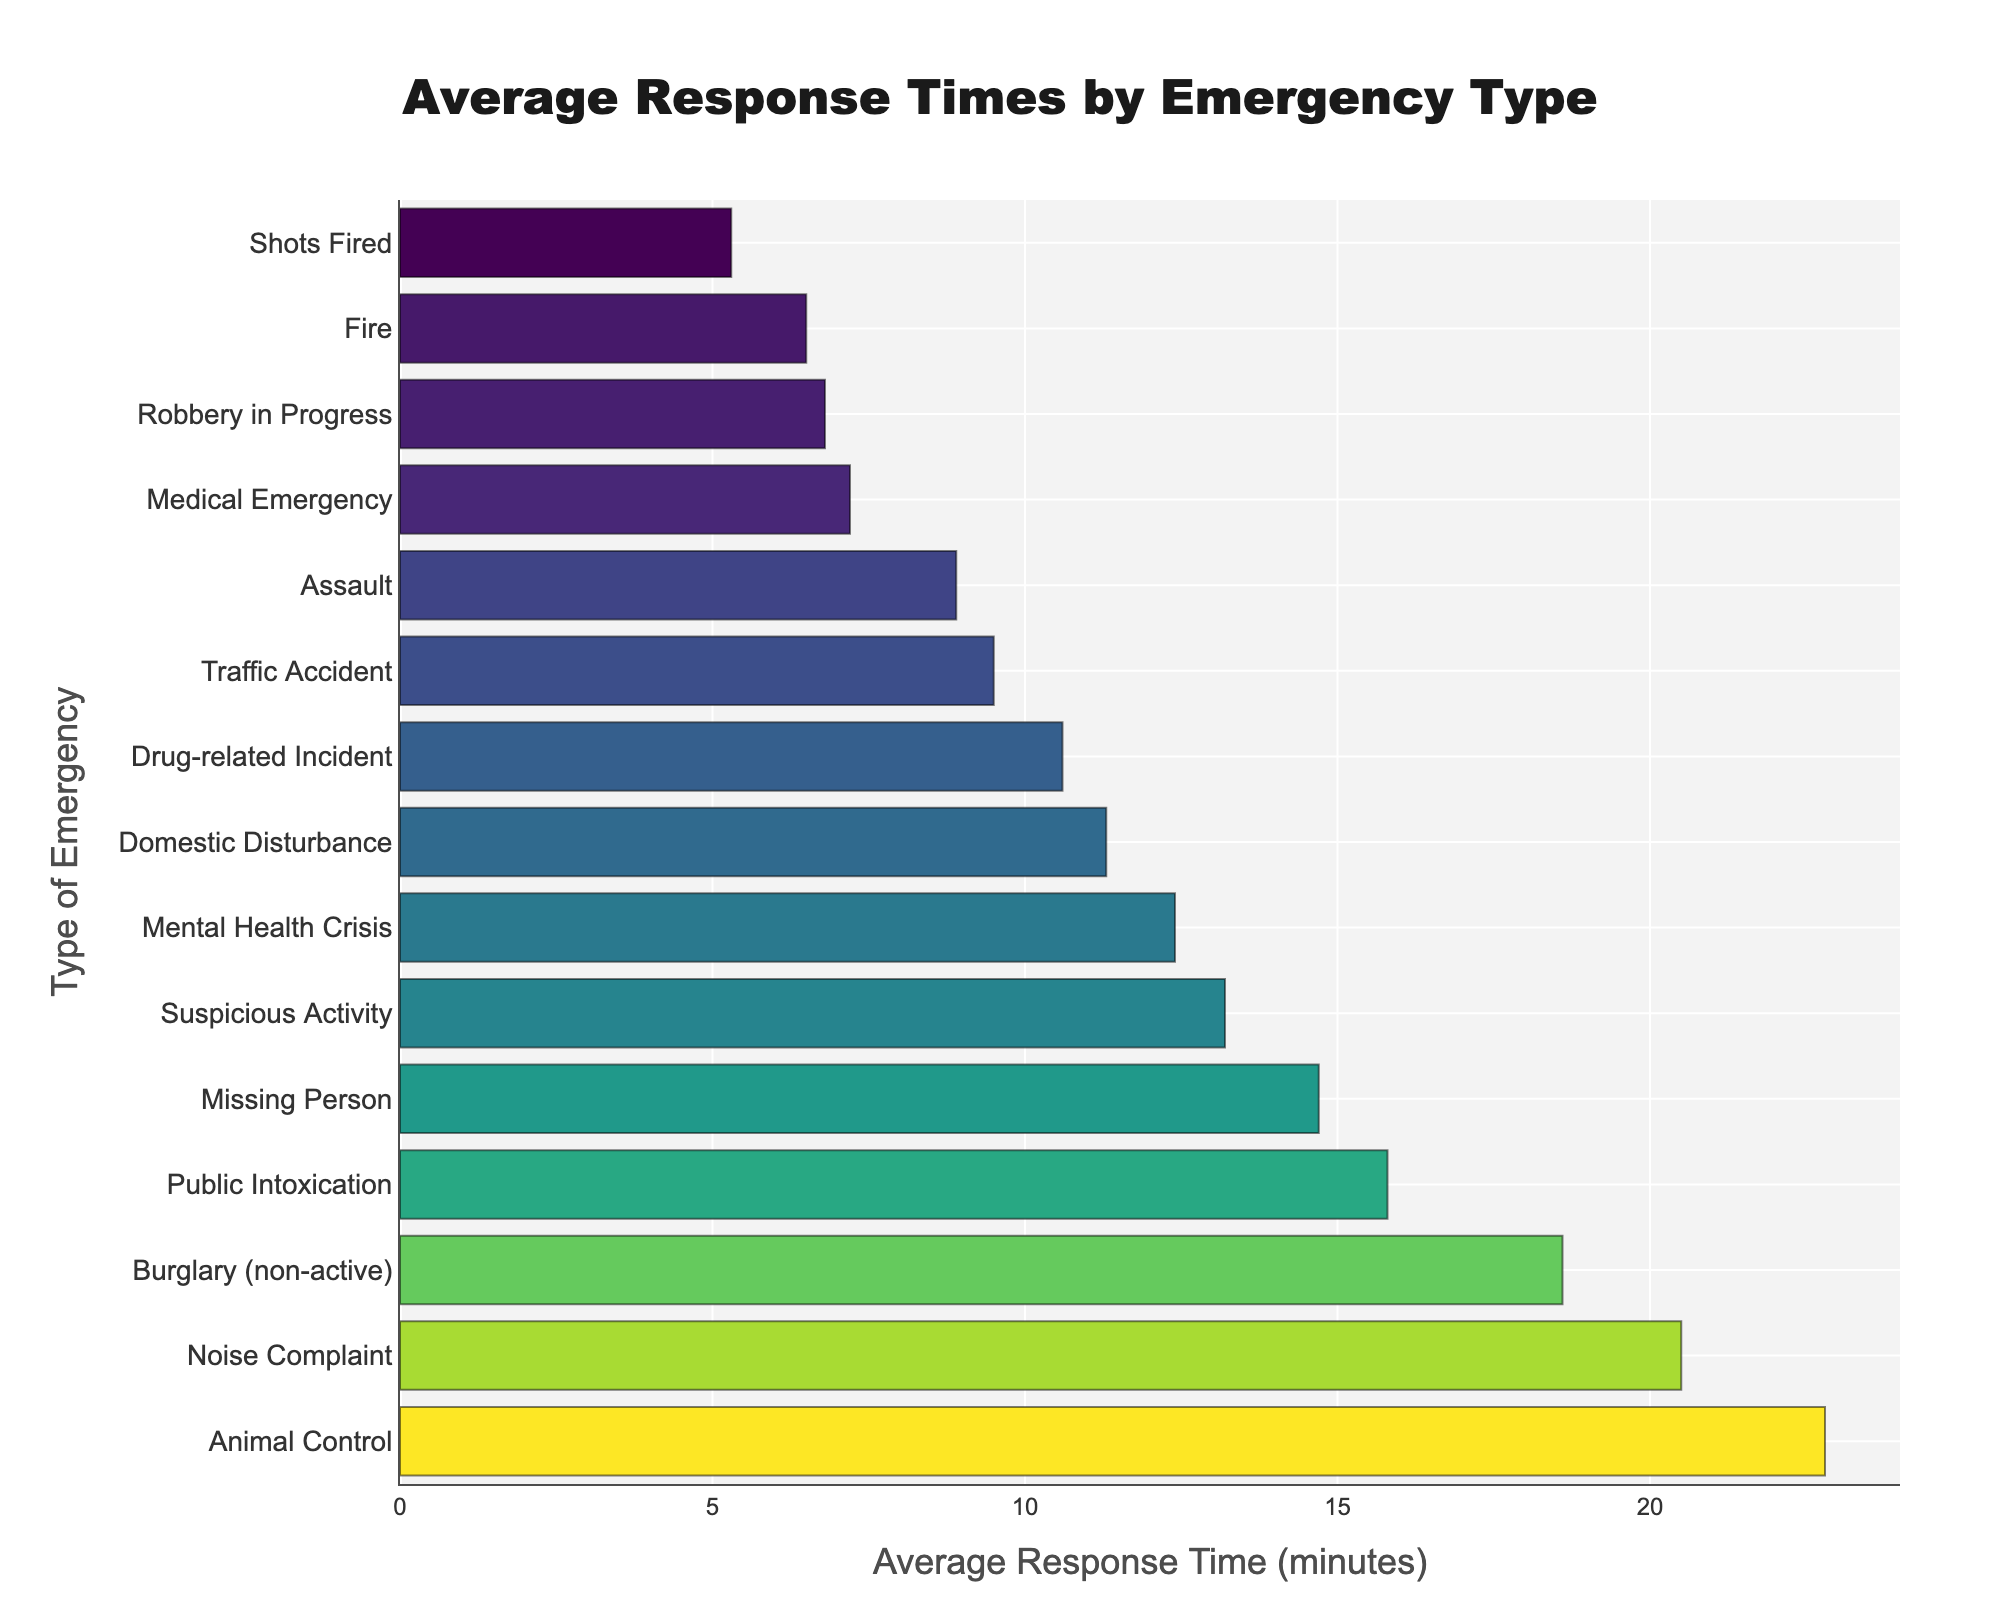What's the type of emergency with the longest average response time? The bar chart shows various types of emergencies along the y-axis with their corresponding average response times on the x-axis. The longest bar represents the longest response time. "Animal Control" has the longest bar, indicating the longest response time.
Answer: Animal Control Which emergency type has an average response time less than 7 minutes? Looking at the bars that have lengths less than the 7-minute mark on the x-axis, "Robbery in Progress," "Fire," and "Shots Fired" meet this criterion.
Answer: Robbery in Progress, Fire, Shots Fired What is the difference in response times between a "Medical Emergency" and a "Noise Complaint"? The bar for "Noise Complaint" has a value of 20.5 minutes, and the bar for "Medical Emergency" has a value of 7.2 minutes. The difference is 20.5 - 7.2.
Answer: 13.3 minutes How does the response time for "Traffic Accident" compare to "Domestic Disturbance"? According to the bars' lengths, "Traffic Accident" has a response time of 9.5 minutes, while "Domestic Disturbance" has a response time of 11.3 minutes, making the "Domestic Disturbance" response time longer.
Answer: Domestic Disturbance is longer What's the sum of response times for "Drug-related Incident" and "Mental Health Crisis"? The bar for "Drug-related Incident" shows a response time of 10.6 minutes, and the bar for "Mental Health Crisis" shows 12.4 minutes. Summing these gives 10.6 + 12.4.
Answer: 23 minutes Identify the three emergencies with the shortest response times. Observing the three shortest bars in the chart reveals that the emergencies are "Shots Fired" (5.3 minutes), "Fire" (6.5 minutes), and "Robbery in Progress" (6.8 minutes).
Answer: Shots Fired, Fire, Robbery in Progress What is the average response time for "Missing Person" and "Suspicious Activity"? "Missing Person" has a response time of 14.7 minutes, and "Suspicious Activity" has 13.2 minutes. The average is computed as (14.7 + 13.2) / 2.
Answer: 13.95 minutes Which emergency has a longer response time: "Public Intoxication" or "Animal Control"? By visual inspection of the lengths of their bars, "Animal Control" has a response time of 22.8 minutes whereas "Public Intoxication" has 15.8 minutes; "Animal Control" has a longer response time.
Answer: Animal Control What is the exact response time for a "Burglary (non-active)"? Referencing the specific bar for "Burglary (non-active)," it shows a response time of 18.6 minutes.
Answer: 18.6 minutes 